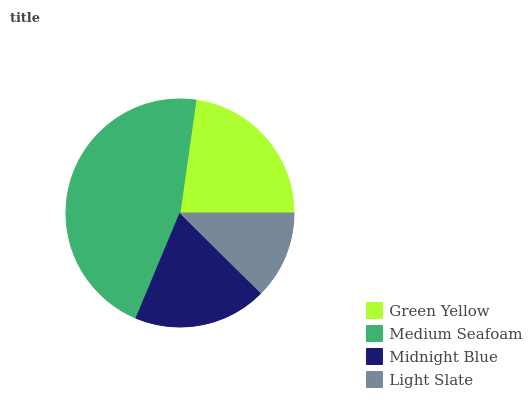Is Light Slate the minimum?
Answer yes or no. Yes. Is Medium Seafoam the maximum?
Answer yes or no. Yes. Is Midnight Blue the minimum?
Answer yes or no. No. Is Midnight Blue the maximum?
Answer yes or no. No. Is Medium Seafoam greater than Midnight Blue?
Answer yes or no. Yes. Is Midnight Blue less than Medium Seafoam?
Answer yes or no. Yes. Is Midnight Blue greater than Medium Seafoam?
Answer yes or no. No. Is Medium Seafoam less than Midnight Blue?
Answer yes or no. No. Is Green Yellow the high median?
Answer yes or no. Yes. Is Midnight Blue the low median?
Answer yes or no. Yes. Is Medium Seafoam the high median?
Answer yes or no. No. Is Medium Seafoam the low median?
Answer yes or no. No. 